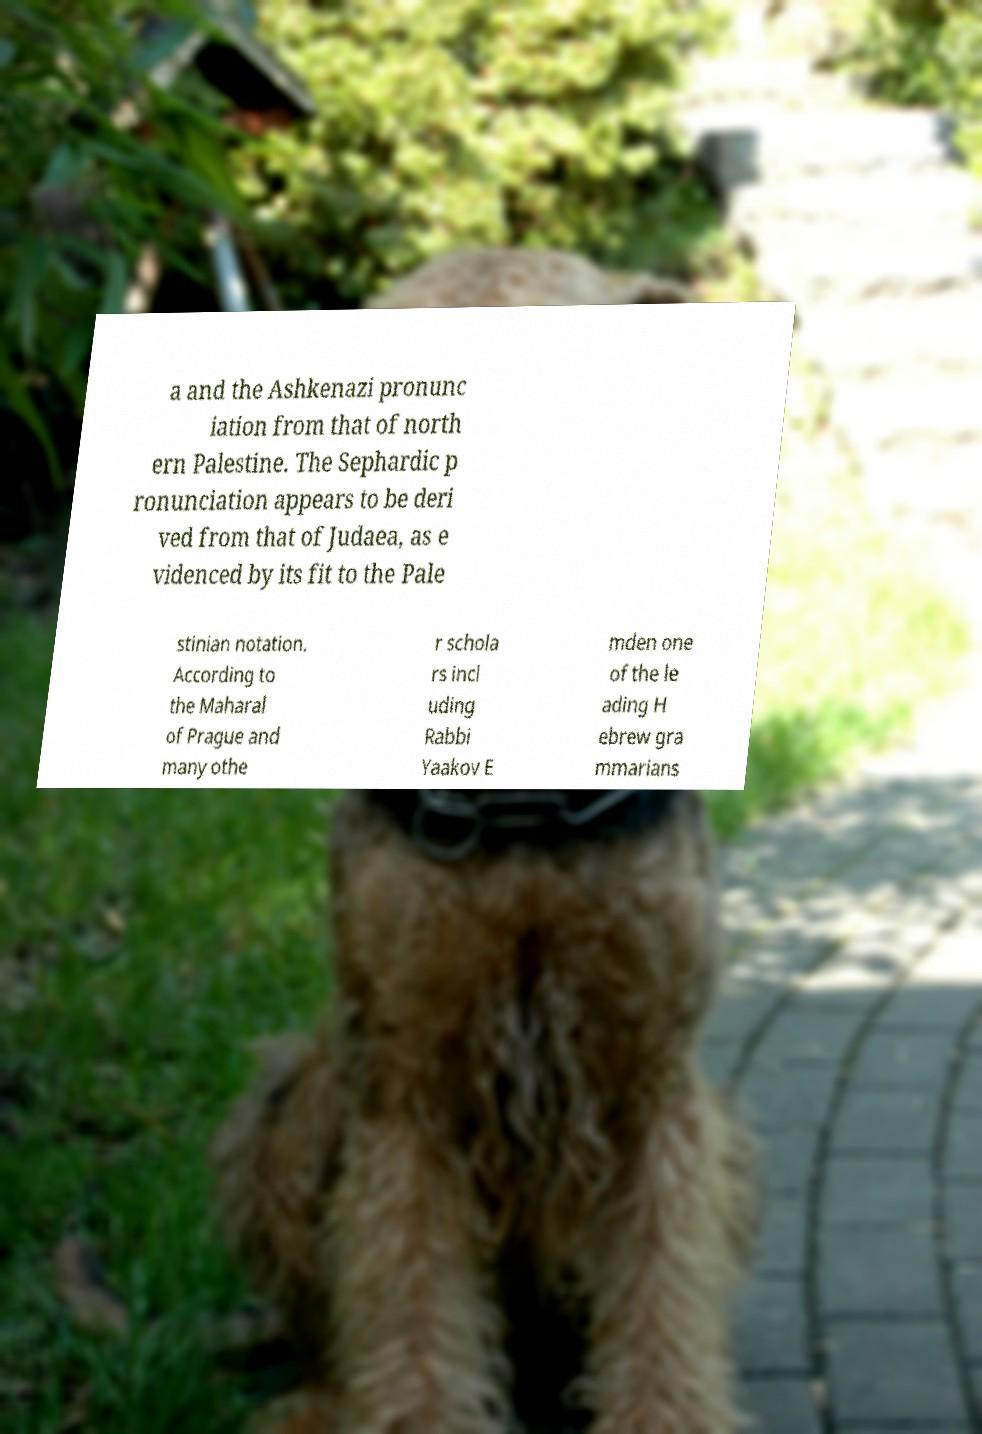For documentation purposes, I need the text within this image transcribed. Could you provide that? a and the Ashkenazi pronunc iation from that of north ern Palestine. The Sephardic p ronunciation appears to be deri ved from that of Judaea, as e videnced by its fit to the Pale stinian notation. According to the Maharal of Prague and many othe r schola rs incl uding Rabbi Yaakov E mden one of the le ading H ebrew gra mmarians 